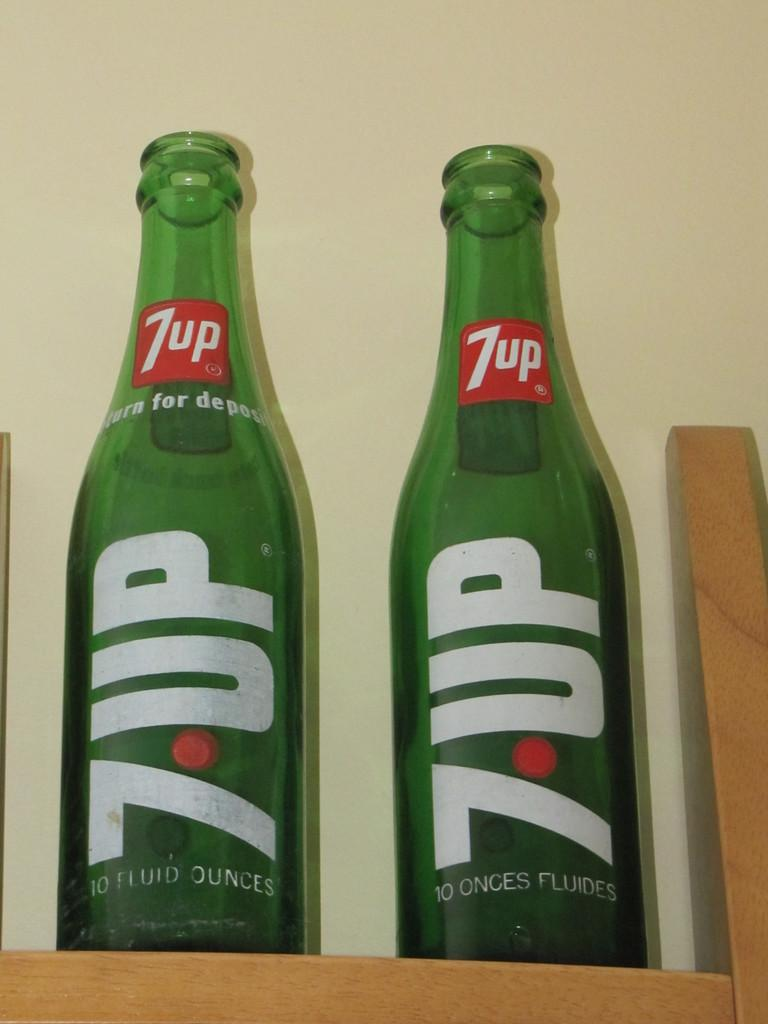Provide a one-sentence caption for the provided image. Two bottles of "7 UP" are next to each other. 